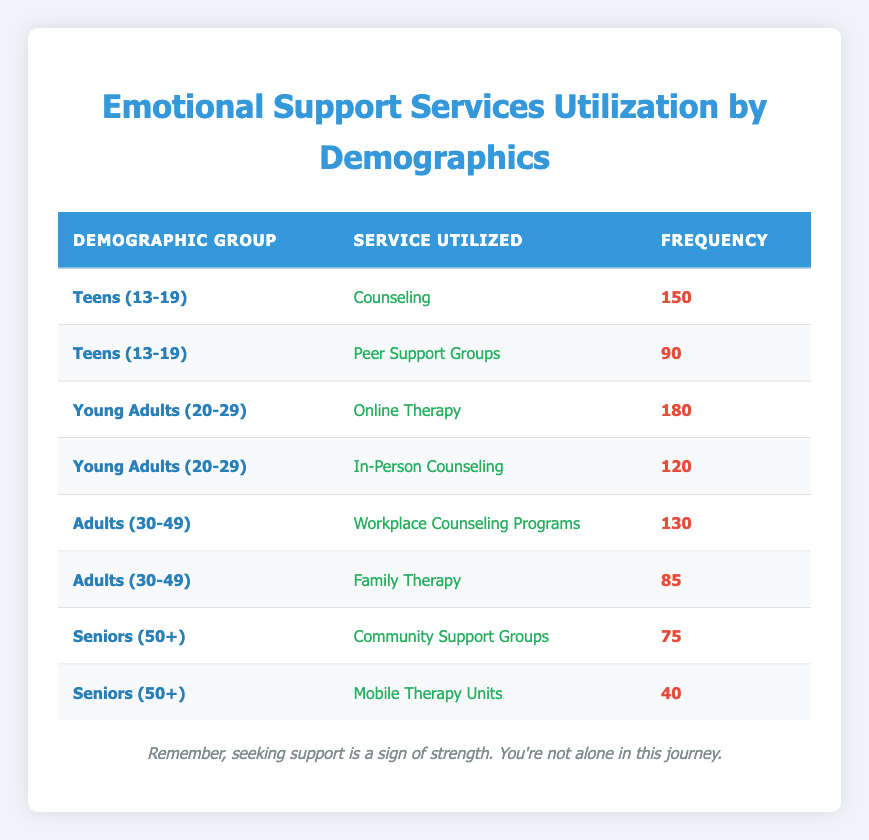What is the total frequency of counseling services utilized by Teens (13-19)? The table shows that Teens (13-19) utilized Counseling with a frequency of 150. Therefore, the total frequency for this service is simply this value.
Answer: 150 How many different types of emotional support services were utilized by Young Adults (20-29)? Young Adults (20-29) utilized two types of services: Online Therapy and In-Person Counseling. Thus, the count of different services is 2.
Answer: 2 Is it true that the frequency of Workplace Counseling Programs is higher than Community Support Groups? The frequency for Workplace Counseling Programs is 130, and for Community Support Groups, it is 75. Since 130 is greater than 75, the statement is true.
Answer: Yes What is the average frequency of services utilized by the Adults (30-49) demographic group? The Adults (30-49) utilized two services with frequencies of 130 and 85. To find the average, we add these two frequencies (130 + 85 = 215) and divide by the number of services (2). Thus, the average frequency is 215 / 2 = 107.5.
Answer: 107.5 Which demographic group utilized the highest frequency of services based on the table? By comparing the frequencies across all demographic groups, we find that Young Adults (20-29) utilized Online Therapy (180), which is the highest frequency of services documented in the table.
Answer: Young Adults (20-29) 